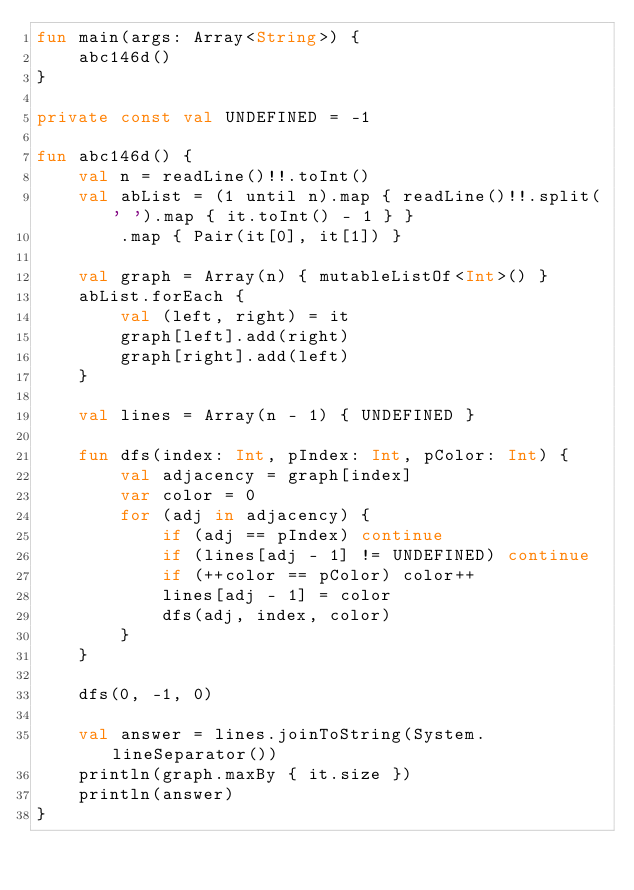<code> <loc_0><loc_0><loc_500><loc_500><_Kotlin_>fun main(args: Array<String>) {
    abc146d()
}

private const val UNDEFINED = -1

fun abc146d() {
    val n = readLine()!!.toInt()
    val abList = (1 until n).map { readLine()!!.split(' ').map { it.toInt() - 1 } }
        .map { Pair(it[0], it[1]) }

    val graph = Array(n) { mutableListOf<Int>() }
    abList.forEach {
        val (left, right) = it
        graph[left].add(right)
        graph[right].add(left)
    }

    val lines = Array(n - 1) { UNDEFINED }

    fun dfs(index: Int, pIndex: Int, pColor: Int) {
        val adjacency = graph[index]
        var color = 0
        for (adj in adjacency) {
            if (adj == pIndex) continue
            if (lines[adj - 1] != UNDEFINED) continue
            if (++color == pColor) color++
            lines[adj - 1] = color
            dfs(adj, index, color)
        }
    }

    dfs(0, -1, 0)

    val answer = lines.joinToString(System.lineSeparator())
    println(graph.maxBy { it.size })
    println(answer)
}
</code> 